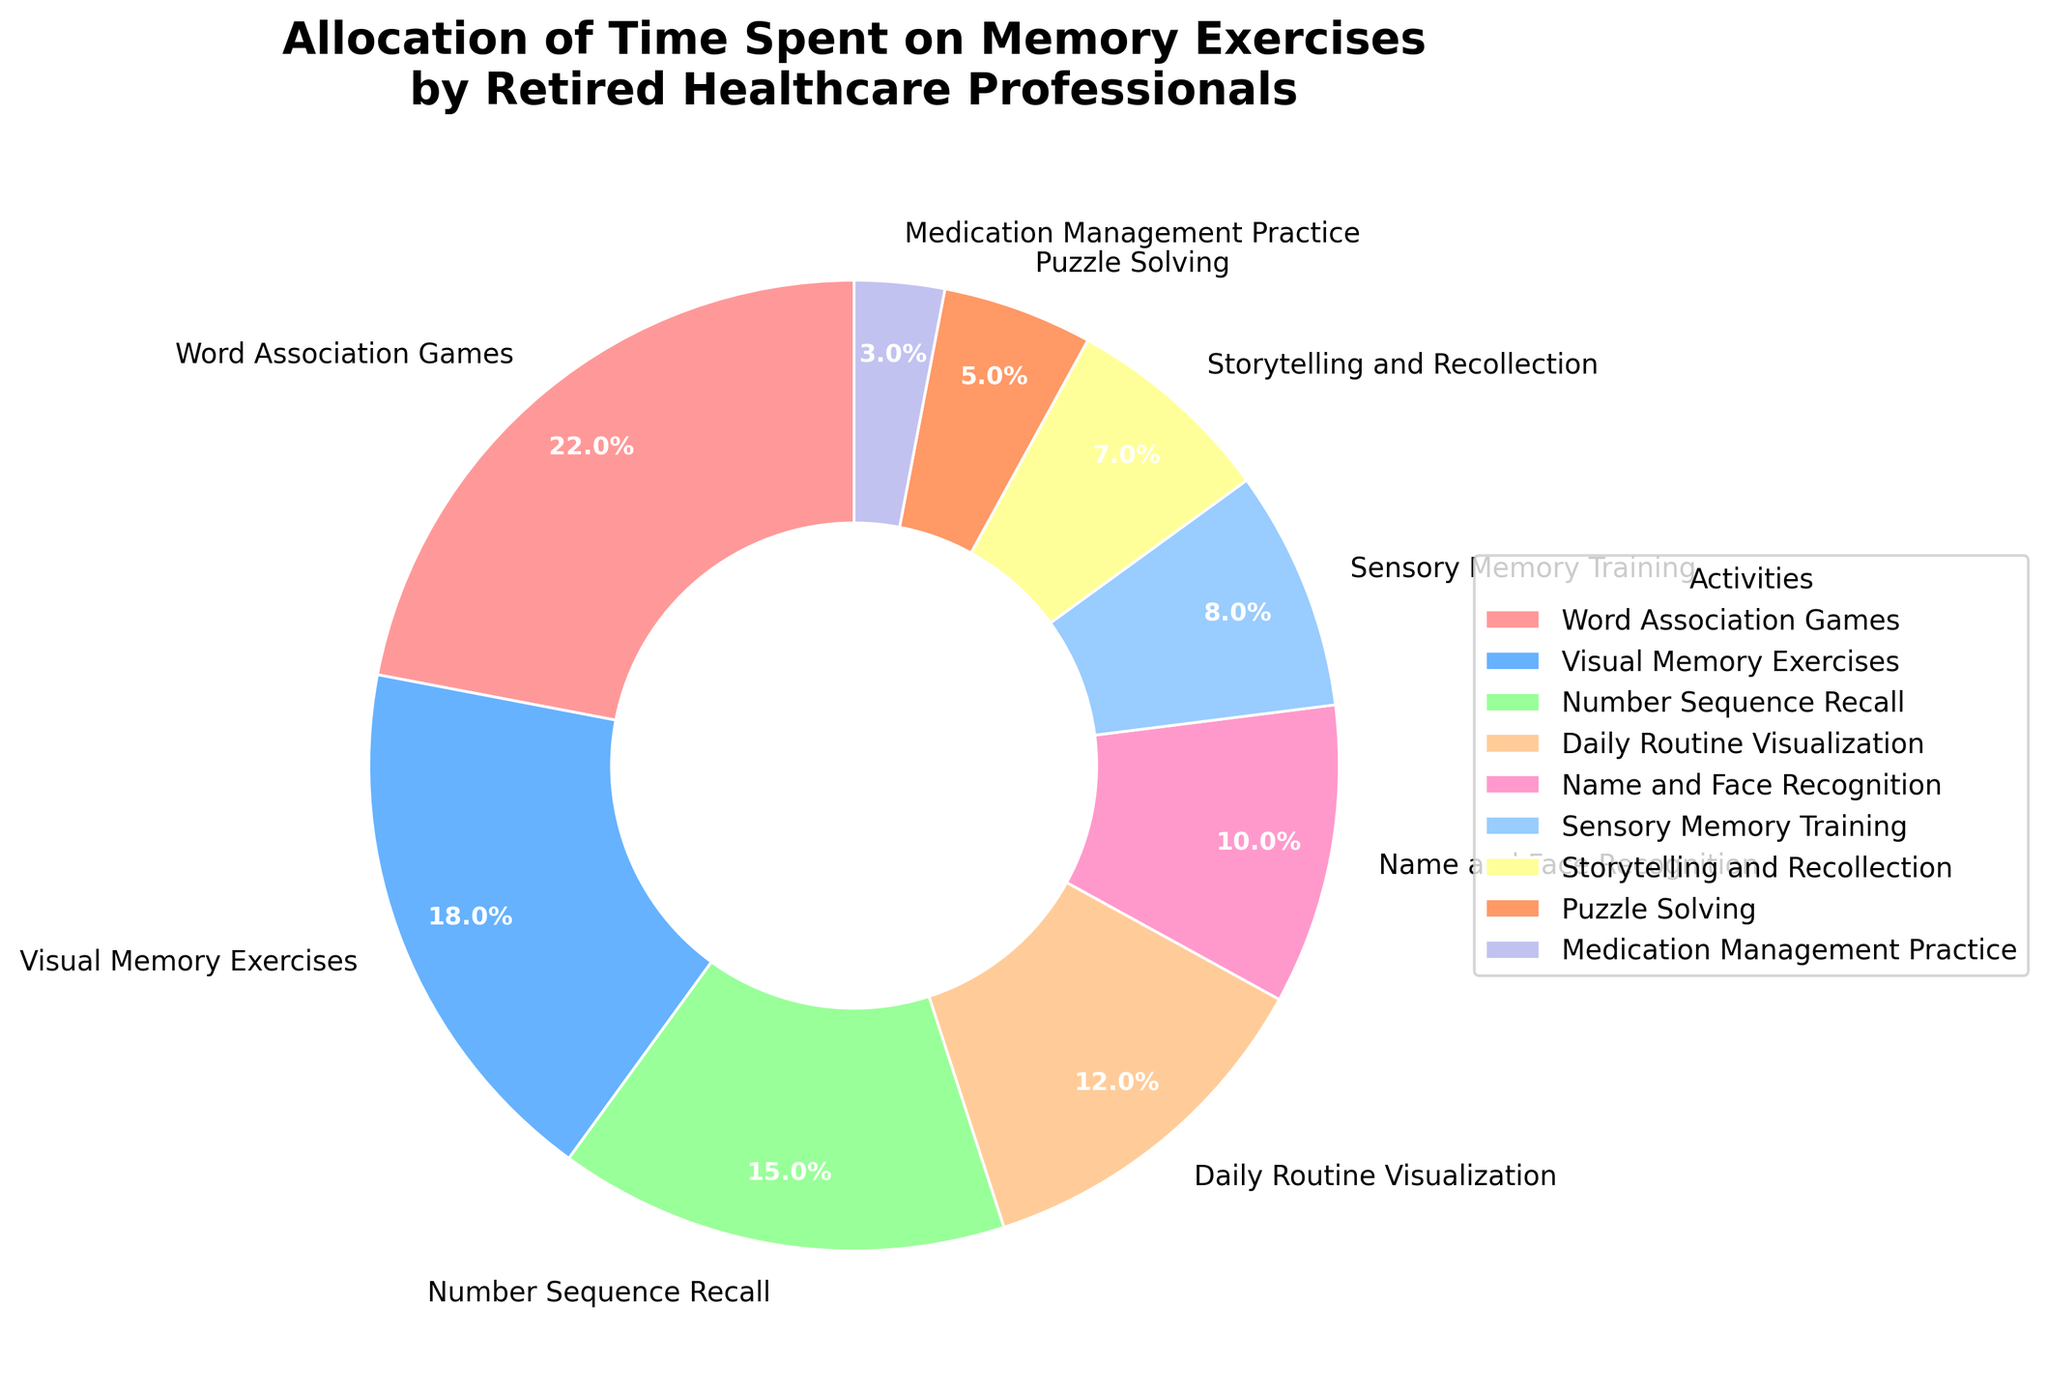What's the total percentage of time spent on Sensory Memory Training and Puzzle Solving combined? To find the combined percentage, add the percentages for Sensory Memory Training (8%) and Puzzle Solving (5%). 8 + 5 = 13
Answer: 13% Which activity takes up the most time in the schedule? Identify the activity with the highest percentage. Word Association Games has the highest percentage at 22%.
Answer: Word Association Games Are Number Sequence Recall and Daily Routine Visualization together greater than Visual Memory Exercises in percentage? Add the percentages for Number Sequence Recall (15%) and Daily Routine Visualization (12%) to get 27%. Compare this with Visual Memory Exercises (18%). 27% is greater than 18%.
Answer: Yes What is the percentage difference between Name and Face Recognition and Storytelling and Recollection? Subtract the percentage of Storytelling and Recollection (7%) from Name and Face Recognition (10%). 10 - 7 = 3
Answer: 3% What color represents Medication Management Practice on the chart? The color representing Medication Management Practice is purple.
Answer: Purple How much more time is spent on Word Association Games compared to Sensory Memory Training? Subtract the percentage of Sensory Memory Training (8%) from the percentage of Word Association Games (22%). 22 - 8 = 14
Answer: 14% Is Visual Memory Exercises allocated more or less time compared to Number Sequence Recall? Compare the percentages of Visual Memory Exercises (18%) and Number Sequence Recall (15%). Visual Memory Exercises (18%) is more.
Answer: More What is the combined percentage for the activities that are allocated less than 10% each? Add the percentages for Name and Face Recognition (10%), Sensory Memory Training (8%), Storytelling and Recollection (7%), Puzzle Solving (5%), and Medication Management Practice (3%). 10 + 8 + 7 + 5 + 3 = 33
Answer: 33% Which two activities together make up exactly 40% of the total time? Add the percentages for various combinations to find the pair that sums to 40%. Number Sequence Recall (15%) + Daily Routine Visualization (12%) + Puzzle Solving (5%) + Storytelling and Recollection (7%) = 40%
Answer: Number Sequence Recall and Daily Routine Visualization 